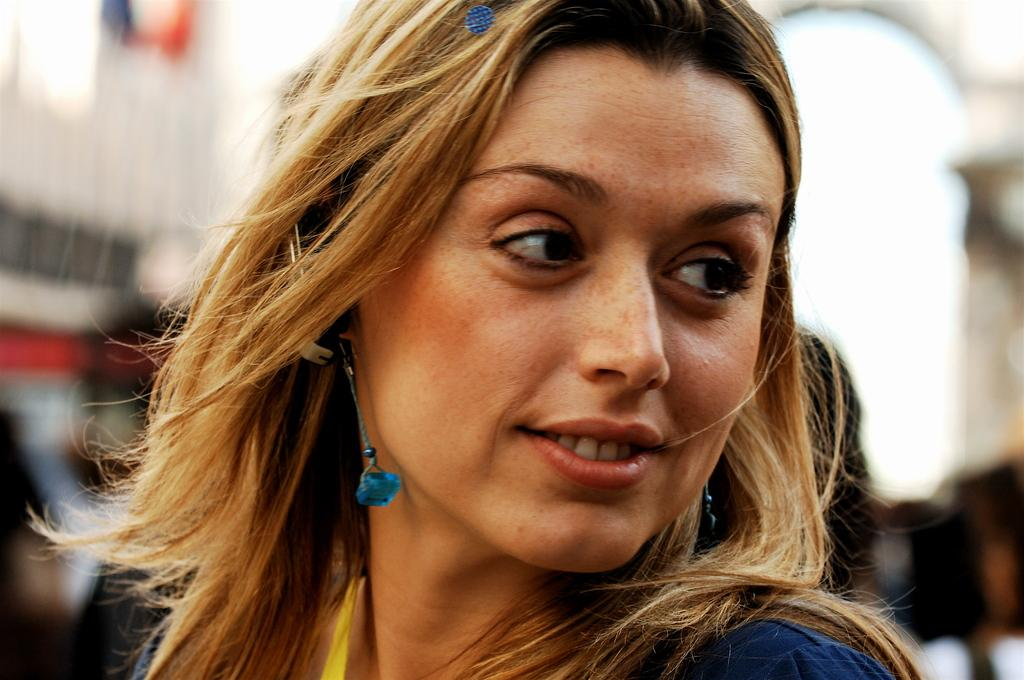What is the main subject of the image? There is a person in the image. What is the person wearing? The person is wearing a blue dress. Can you describe the background of the image? The background of the image is blurred. What type of bean is visible in the image? There is no bean present in the image. What kind of rock can be seen in the background of the image? There is no rock visible in the image, as the background is blurred. 